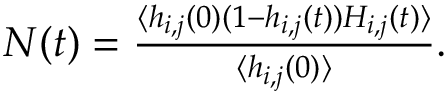Convert formula to latex. <formula><loc_0><loc_0><loc_500><loc_500>\begin{array} { r } { N ( t ) = \frac { \langle h _ { i , j } ( 0 ) ( 1 - h _ { i , j } ( t ) ) H _ { i , j } ( t ) \rangle } { \langle h _ { i , j } ( 0 ) \rangle } . } \end{array}</formula> 